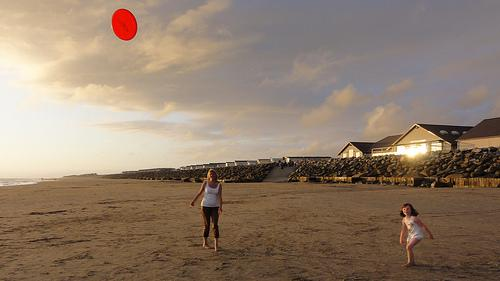Question: who is running towards the frisbee?
Choices:
A. The dog.
B. The man.
C. The girl.
D. A boy.
Answer with the letter. Answer: C Question: what color is the woman's shirt?
Choices:
A. Black.
B. Red.
C. Blue.
D. White.
Answer with the letter. Answer: D Question: what is in the sky?
Choices:
A. Stars.
B. A plane.
C. Birds.
D. Clouds.
Answer with the letter. Answer: D Question: why is the girl running?
Choices:
A. To reach first base.
B. To catch a bus.
C. To win the race.
D. To catch the frisbee.
Answer with the letter. Answer: D Question: what color is the frisbee?
Choices:
A. Red.
B. White.
C. Black.
D. Pink.
Answer with the letter. Answer: A Question: what is covering the ground?
Choices:
A. Sand.
B. Leaves.
C. Snow.
D. A tarp.
Answer with the letter. Answer: A Question: what covers the slopes in the background?
Choices:
A. Rocks.
B. Snow.
C. Grass.
D. Trees.
Answer with the letter. Answer: A 